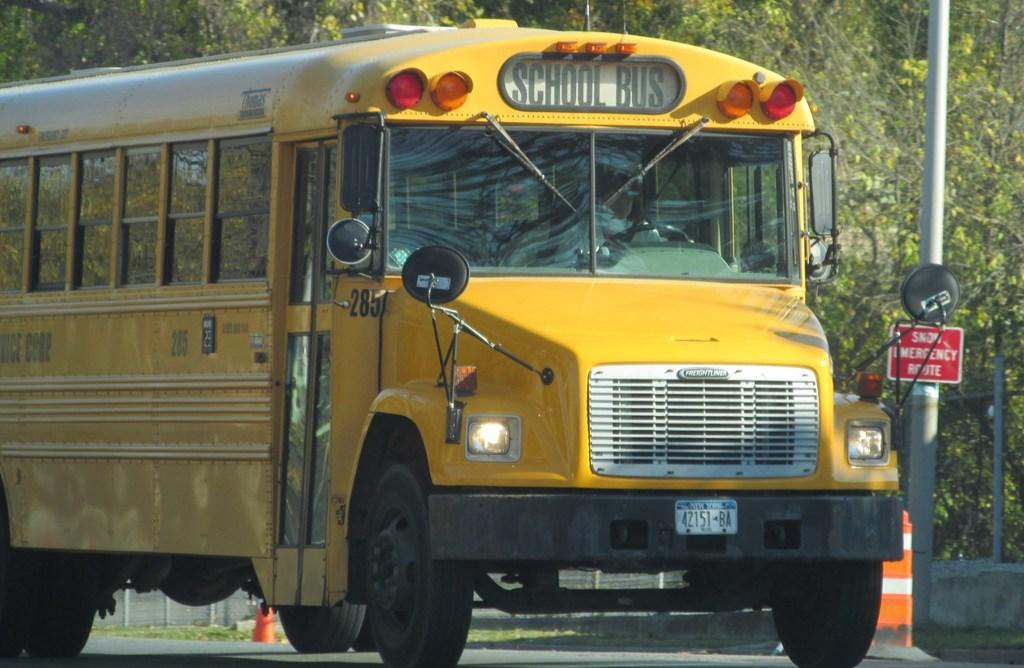What type of vehicle is on the ground in the image? There is a bus on the ground in the image. What can be seen on the signboard in the image? There is a signboard with text in the image. What structures are visible in the image? Poles and a fence are visible in the image. What type of vegetation is present in the image? Grass and a group of trees are present in the image. Can you tell me how many cats are sitting on the bus in the image? There are no cats present in the image; it features a bus on the ground. What type of support is provided by the poles in the image? The poles in the image do not provide any visible support for other structures; they are simply standing upright. 